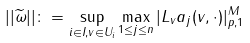<formula> <loc_0><loc_0><loc_500><loc_500>| | \widetilde { \omega } | | \colon = \sup _ { i \in I , v \in U _ { i } } \max _ { 1 \leq j \leq n } | L _ { v } a _ { j } ( v , \cdot ) | _ { p , 1 } ^ { M }</formula> 